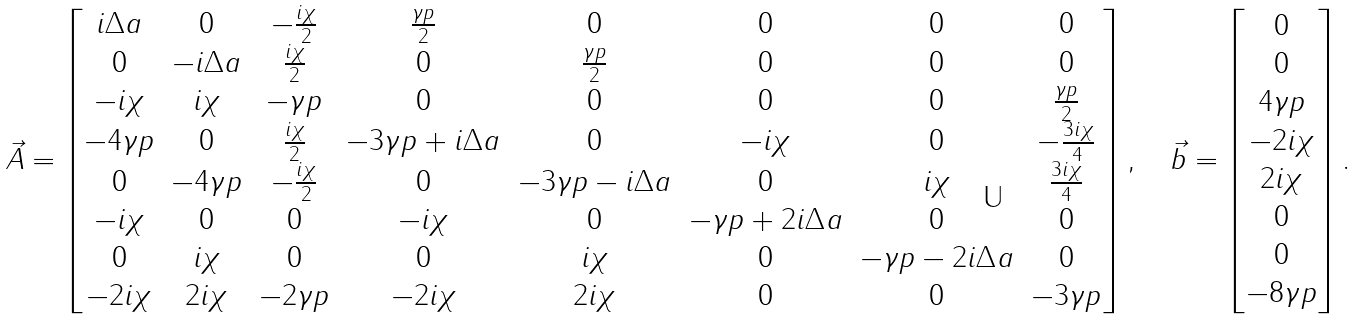Convert formula to latex. <formula><loc_0><loc_0><loc_500><loc_500>\vec { A } = \begin{bmatrix} i \Delta a & 0 & - \frac { i \chi } { 2 } & \frac { \gamma p } { 2 } & 0 & 0 & 0 & 0 \\ 0 & - i \Delta a & \frac { i \chi } { 2 } & 0 & \frac { \gamma p } { 2 } & 0 & 0 & 0 \\ - i \chi & i \chi & - \gamma p & 0 & 0 & 0 & 0 & \frac { \gamma p } { 2 } \\ - 4 \gamma p & 0 & \frac { i \chi } { 2 } & - 3 \gamma p + i \Delta a & 0 & - i \chi & 0 & - \frac { 3 i \chi } { 4 } \\ 0 & - 4 \gamma p & - \frac { i \chi } { 2 } & 0 & - 3 \gamma p - i \Delta a & 0 & i \chi & \frac { 3 i \chi } { 4 } \\ - i \chi & 0 & 0 & - i \chi & 0 & - \gamma p + 2 i \Delta a & 0 & 0 \\ 0 & i \chi & 0 & 0 & i \chi & 0 & - \gamma p - 2 i \Delta a & 0 \\ - 2 i \chi & 2 i \chi & - 2 \gamma p & - 2 i \chi & 2 i \chi & 0 & 0 & - 3 \gamma p \end{bmatrix} , \quad \vec { b } = \begin{bmatrix} 0 \\ 0 \\ 4 \gamma p \\ - 2 i \chi \\ 2 i \chi \\ 0 \\ 0 \\ - 8 \gamma p \end{bmatrix} .</formula> 